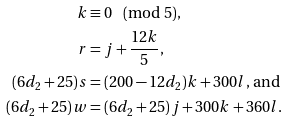Convert formula to latex. <formula><loc_0><loc_0><loc_500><loc_500>k & \equiv 0 \pmod { 5 } , \\ r & = j + \frac { 1 2 k } { 5 } , \\ ( 6 d _ { 2 } + 2 5 ) s & = ( 2 0 0 - 1 2 d _ { 2 } ) k + 3 0 0 l , \, \text {and} \\ ( 6 d _ { 2 } + 2 5 ) w & = ( 6 d _ { 2 } + 2 5 ) j + 3 0 0 k + 3 6 0 l .</formula> 